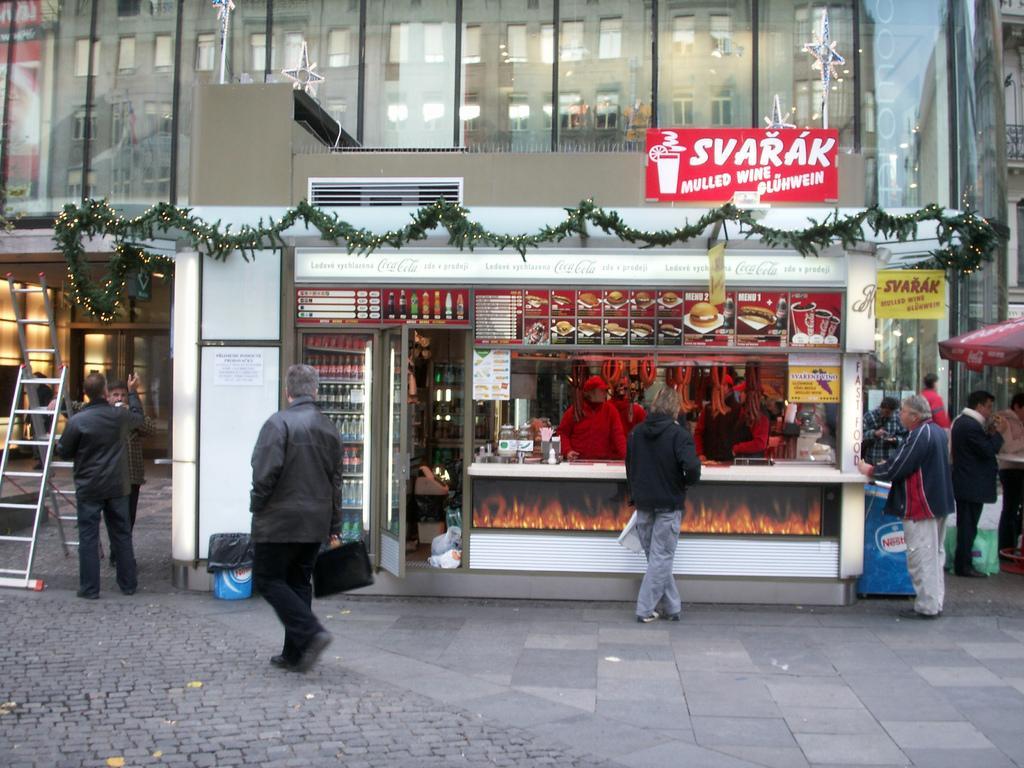How would you summarize this image in a sentence or two? In the foreground of this image, there are persons walking and standing on the pavement. In the middle, there is a stool and few decorations to it. On the right, there is an umbrella. On the left, there is a ladder. In the background, there are buildings and on the top, there are star poles on the stool. 